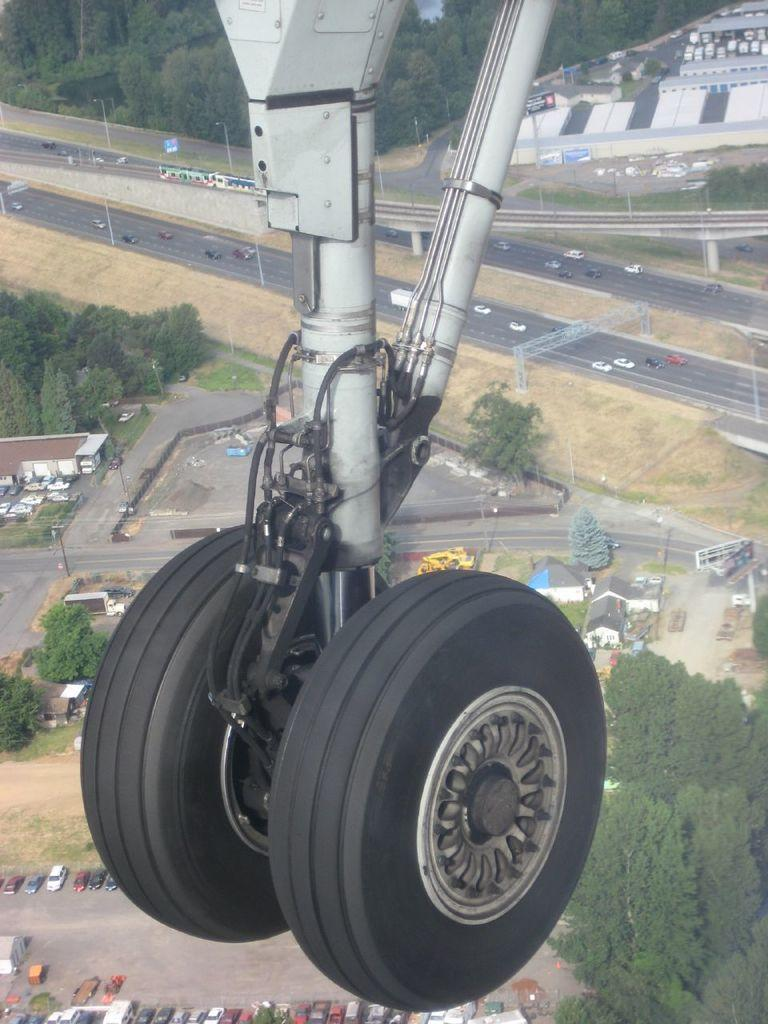What type of object is featured in the image? There are airplane tires in the image. What else can be seen in the image besides the airplane tires? Buildings, vehicles, and trees are visible in the image. Where are the vehicles located in the image? There are vehicles on the road in the image. Can you describe the background of the image? The background of the image includes trees. What type of leather is used to make the airplane tires in the image? Airplane tires are not made of leather; they are made of rubber. What is the weight of the route visible in the image? There is no route visible in the image, and therefore its weight cannot be determined. 